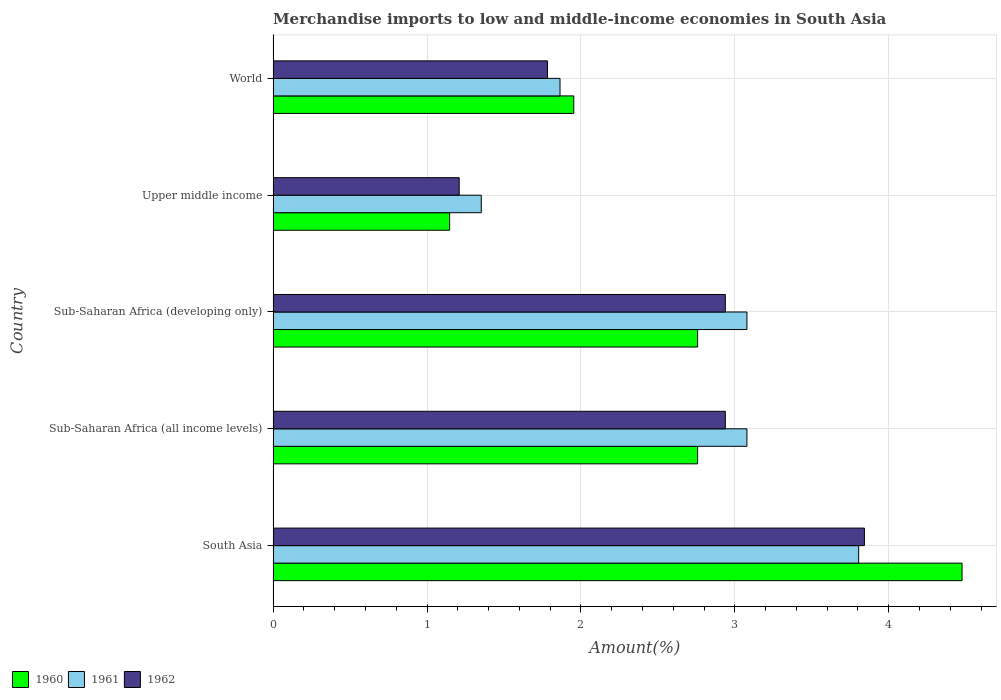How many different coloured bars are there?
Your response must be concise. 3. Are the number of bars on each tick of the Y-axis equal?
Provide a succinct answer. Yes. How many bars are there on the 1st tick from the top?
Offer a very short reply. 3. What is the label of the 1st group of bars from the top?
Your answer should be compact. World. In how many cases, is the number of bars for a given country not equal to the number of legend labels?
Provide a short and direct response. 0. What is the percentage of amount earned from merchandise imports in 1961 in World?
Your response must be concise. 1.86. Across all countries, what is the maximum percentage of amount earned from merchandise imports in 1960?
Provide a succinct answer. 4.48. Across all countries, what is the minimum percentage of amount earned from merchandise imports in 1962?
Your answer should be compact. 1.21. In which country was the percentage of amount earned from merchandise imports in 1961 minimum?
Make the answer very short. Upper middle income. What is the total percentage of amount earned from merchandise imports in 1961 in the graph?
Offer a very short reply. 13.18. What is the difference between the percentage of amount earned from merchandise imports in 1961 in Sub-Saharan Africa (all income levels) and that in Sub-Saharan Africa (developing only)?
Offer a terse response. 0. What is the difference between the percentage of amount earned from merchandise imports in 1960 in Sub-Saharan Africa (all income levels) and the percentage of amount earned from merchandise imports in 1962 in World?
Your answer should be very brief. 0.98. What is the average percentage of amount earned from merchandise imports in 1962 per country?
Your response must be concise. 2.54. What is the difference between the percentage of amount earned from merchandise imports in 1961 and percentage of amount earned from merchandise imports in 1960 in Sub-Saharan Africa (developing only)?
Give a very brief answer. 0.32. What is the ratio of the percentage of amount earned from merchandise imports in 1962 in South Asia to that in Sub-Saharan Africa (all income levels)?
Your response must be concise. 1.31. Is the percentage of amount earned from merchandise imports in 1960 in South Asia less than that in Sub-Saharan Africa (developing only)?
Keep it short and to the point. No. Is the difference between the percentage of amount earned from merchandise imports in 1961 in Sub-Saharan Africa (developing only) and World greater than the difference between the percentage of amount earned from merchandise imports in 1960 in Sub-Saharan Africa (developing only) and World?
Your answer should be very brief. Yes. What is the difference between the highest and the second highest percentage of amount earned from merchandise imports in 1961?
Make the answer very short. 0.73. What is the difference between the highest and the lowest percentage of amount earned from merchandise imports in 1960?
Your answer should be compact. 3.33. In how many countries, is the percentage of amount earned from merchandise imports in 1960 greater than the average percentage of amount earned from merchandise imports in 1960 taken over all countries?
Your response must be concise. 3. Is the sum of the percentage of amount earned from merchandise imports in 1960 in Sub-Saharan Africa (all income levels) and Upper middle income greater than the maximum percentage of amount earned from merchandise imports in 1962 across all countries?
Your answer should be compact. Yes. What does the 2nd bar from the bottom in World represents?
Keep it short and to the point. 1961. Are the values on the major ticks of X-axis written in scientific E-notation?
Keep it short and to the point. No. Where does the legend appear in the graph?
Offer a very short reply. Bottom left. How many legend labels are there?
Give a very brief answer. 3. What is the title of the graph?
Ensure brevity in your answer.  Merchandise imports to low and middle-income economies in South Asia. Does "1993" appear as one of the legend labels in the graph?
Keep it short and to the point. No. What is the label or title of the X-axis?
Offer a very short reply. Amount(%). What is the label or title of the Y-axis?
Offer a terse response. Country. What is the Amount(%) of 1960 in South Asia?
Keep it short and to the point. 4.48. What is the Amount(%) of 1961 in South Asia?
Make the answer very short. 3.8. What is the Amount(%) in 1962 in South Asia?
Offer a very short reply. 3.84. What is the Amount(%) of 1960 in Sub-Saharan Africa (all income levels)?
Keep it short and to the point. 2.76. What is the Amount(%) in 1961 in Sub-Saharan Africa (all income levels)?
Make the answer very short. 3.08. What is the Amount(%) of 1962 in Sub-Saharan Africa (all income levels)?
Offer a very short reply. 2.94. What is the Amount(%) in 1960 in Sub-Saharan Africa (developing only)?
Make the answer very short. 2.76. What is the Amount(%) in 1961 in Sub-Saharan Africa (developing only)?
Your response must be concise. 3.08. What is the Amount(%) in 1962 in Sub-Saharan Africa (developing only)?
Provide a succinct answer. 2.94. What is the Amount(%) in 1960 in Upper middle income?
Offer a very short reply. 1.15. What is the Amount(%) in 1961 in Upper middle income?
Keep it short and to the point. 1.35. What is the Amount(%) of 1962 in Upper middle income?
Your answer should be very brief. 1.21. What is the Amount(%) in 1960 in World?
Keep it short and to the point. 1.95. What is the Amount(%) in 1961 in World?
Ensure brevity in your answer.  1.86. What is the Amount(%) in 1962 in World?
Offer a very short reply. 1.78. Across all countries, what is the maximum Amount(%) of 1960?
Offer a terse response. 4.48. Across all countries, what is the maximum Amount(%) in 1961?
Your answer should be compact. 3.8. Across all countries, what is the maximum Amount(%) of 1962?
Keep it short and to the point. 3.84. Across all countries, what is the minimum Amount(%) of 1960?
Ensure brevity in your answer.  1.15. Across all countries, what is the minimum Amount(%) of 1961?
Offer a terse response. 1.35. Across all countries, what is the minimum Amount(%) in 1962?
Offer a very short reply. 1.21. What is the total Amount(%) of 1960 in the graph?
Offer a very short reply. 13.09. What is the total Amount(%) in 1961 in the graph?
Make the answer very short. 13.18. What is the total Amount(%) in 1962 in the graph?
Your answer should be compact. 12.71. What is the difference between the Amount(%) of 1960 in South Asia and that in Sub-Saharan Africa (all income levels)?
Provide a succinct answer. 1.72. What is the difference between the Amount(%) in 1961 in South Asia and that in Sub-Saharan Africa (all income levels)?
Keep it short and to the point. 0.73. What is the difference between the Amount(%) of 1962 in South Asia and that in Sub-Saharan Africa (all income levels)?
Offer a very short reply. 0.9. What is the difference between the Amount(%) in 1960 in South Asia and that in Sub-Saharan Africa (developing only)?
Give a very brief answer. 1.72. What is the difference between the Amount(%) in 1961 in South Asia and that in Sub-Saharan Africa (developing only)?
Provide a short and direct response. 0.73. What is the difference between the Amount(%) of 1962 in South Asia and that in Sub-Saharan Africa (developing only)?
Your answer should be very brief. 0.9. What is the difference between the Amount(%) of 1960 in South Asia and that in Upper middle income?
Provide a short and direct response. 3.33. What is the difference between the Amount(%) of 1961 in South Asia and that in Upper middle income?
Your answer should be very brief. 2.45. What is the difference between the Amount(%) of 1962 in South Asia and that in Upper middle income?
Your answer should be compact. 2.63. What is the difference between the Amount(%) in 1960 in South Asia and that in World?
Your response must be concise. 2.52. What is the difference between the Amount(%) in 1961 in South Asia and that in World?
Your response must be concise. 1.94. What is the difference between the Amount(%) in 1962 in South Asia and that in World?
Your response must be concise. 2.06. What is the difference between the Amount(%) in 1961 in Sub-Saharan Africa (all income levels) and that in Sub-Saharan Africa (developing only)?
Provide a succinct answer. 0. What is the difference between the Amount(%) of 1960 in Sub-Saharan Africa (all income levels) and that in Upper middle income?
Your answer should be compact. 1.61. What is the difference between the Amount(%) in 1961 in Sub-Saharan Africa (all income levels) and that in Upper middle income?
Keep it short and to the point. 1.73. What is the difference between the Amount(%) of 1962 in Sub-Saharan Africa (all income levels) and that in Upper middle income?
Your answer should be compact. 1.73. What is the difference between the Amount(%) of 1960 in Sub-Saharan Africa (all income levels) and that in World?
Provide a succinct answer. 0.8. What is the difference between the Amount(%) of 1961 in Sub-Saharan Africa (all income levels) and that in World?
Keep it short and to the point. 1.21. What is the difference between the Amount(%) in 1962 in Sub-Saharan Africa (all income levels) and that in World?
Make the answer very short. 1.16. What is the difference between the Amount(%) in 1960 in Sub-Saharan Africa (developing only) and that in Upper middle income?
Offer a very short reply. 1.61. What is the difference between the Amount(%) in 1961 in Sub-Saharan Africa (developing only) and that in Upper middle income?
Provide a short and direct response. 1.73. What is the difference between the Amount(%) in 1962 in Sub-Saharan Africa (developing only) and that in Upper middle income?
Give a very brief answer. 1.73. What is the difference between the Amount(%) in 1960 in Sub-Saharan Africa (developing only) and that in World?
Provide a succinct answer. 0.8. What is the difference between the Amount(%) in 1961 in Sub-Saharan Africa (developing only) and that in World?
Provide a short and direct response. 1.21. What is the difference between the Amount(%) in 1962 in Sub-Saharan Africa (developing only) and that in World?
Your response must be concise. 1.16. What is the difference between the Amount(%) of 1960 in Upper middle income and that in World?
Provide a succinct answer. -0.81. What is the difference between the Amount(%) of 1961 in Upper middle income and that in World?
Keep it short and to the point. -0.51. What is the difference between the Amount(%) in 1962 in Upper middle income and that in World?
Provide a succinct answer. -0.57. What is the difference between the Amount(%) of 1960 in South Asia and the Amount(%) of 1961 in Sub-Saharan Africa (all income levels)?
Provide a short and direct response. 1.4. What is the difference between the Amount(%) of 1960 in South Asia and the Amount(%) of 1962 in Sub-Saharan Africa (all income levels)?
Your answer should be very brief. 1.54. What is the difference between the Amount(%) of 1961 in South Asia and the Amount(%) of 1962 in Sub-Saharan Africa (all income levels)?
Provide a succinct answer. 0.87. What is the difference between the Amount(%) in 1960 in South Asia and the Amount(%) in 1961 in Sub-Saharan Africa (developing only)?
Make the answer very short. 1.4. What is the difference between the Amount(%) of 1960 in South Asia and the Amount(%) of 1962 in Sub-Saharan Africa (developing only)?
Provide a short and direct response. 1.54. What is the difference between the Amount(%) of 1961 in South Asia and the Amount(%) of 1962 in Sub-Saharan Africa (developing only)?
Your answer should be very brief. 0.87. What is the difference between the Amount(%) of 1960 in South Asia and the Amount(%) of 1961 in Upper middle income?
Your response must be concise. 3.12. What is the difference between the Amount(%) in 1960 in South Asia and the Amount(%) in 1962 in Upper middle income?
Keep it short and to the point. 3.27. What is the difference between the Amount(%) of 1961 in South Asia and the Amount(%) of 1962 in Upper middle income?
Offer a very short reply. 2.6. What is the difference between the Amount(%) of 1960 in South Asia and the Amount(%) of 1961 in World?
Ensure brevity in your answer.  2.61. What is the difference between the Amount(%) in 1960 in South Asia and the Amount(%) in 1962 in World?
Ensure brevity in your answer.  2.69. What is the difference between the Amount(%) in 1961 in South Asia and the Amount(%) in 1962 in World?
Ensure brevity in your answer.  2.02. What is the difference between the Amount(%) of 1960 in Sub-Saharan Africa (all income levels) and the Amount(%) of 1961 in Sub-Saharan Africa (developing only)?
Provide a short and direct response. -0.32. What is the difference between the Amount(%) in 1960 in Sub-Saharan Africa (all income levels) and the Amount(%) in 1962 in Sub-Saharan Africa (developing only)?
Give a very brief answer. -0.18. What is the difference between the Amount(%) in 1961 in Sub-Saharan Africa (all income levels) and the Amount(%) in 1962 in Sub-Saharan Africa (developing only)?
Provide a short and direct response. 0.14. What is the difference between the Amount(%) of 1960 in Sub-Saharan Africa (all income levels) and the Amount(%) of 1961 in Upper middle income?
Your response must be concise. 1.41. What is the difference between the Amount(%) of 1960 in Sub-Saharan Africa (all income levels) and the Amount(%) of 1962 in Upper middle income?
Give a very brief answer. 1.55. What is the difference between the Amount(%) of 1961 in Sub-Saharan Africa (all income levels) and the Amount(%) of 1962 in Upper middle income?
Give a very brief answer. 1.87. What is the difference between the Amount(%) of 1960 in Sub-Saharan Africa (all income levels) and the Amount(%) of 1961 in World?
Keep it short and to the point. 0.89. What is the difference between the Amount(%) in 1960 in Sub-Saharan Africa (all income levels) and the Amount(%) in 1962 in World?
Your response must be concise. 0.98. What is the difference between the Amount(%) in 1961 in Sub-Saharan Africa (all income levels) and the Amount(%) in 1962 in World?
Ensure brevity in your answer.  1.3. What is the difference between the Amount(%) of 1960 in Sub-Saharan Africa (developing only) and the Amount(%) of 1961 in Upper middle income?
Make the answer very short. 1.41. What is the difference between the Amount(%) of 1960 in Sub-Saharan Africa (developing only) and the Amount(%) of 1962 in Upper middle income?
Your response must be concise. 1.55. What is the difference between the Amount(%) of 1961 in Sub-Saharan Africa (developing only) and the Amount(%) of 1962 in Upper middle income?
Offer a terse response. 1.87. What is the difference between the Amount(%) of 1960 in Sub-Saharan Africa (developing only) and the Amount(%) of 1961 in World?
Give a very brief answer. 0.89. What is the difference between the Amount(%) in 1960 in Sub-Saharan Africa (developing only) and the Amount(%) in 1962 in World?
Offer a terse response. 0.98. What is the difference between the Amount(%) in 1961 in Sub-Saharan Africa (developing only) and the Amount(%) in 1962 in World?
Offer a very short reply. 1.3. What is the difference between the Amount(%) of 1960 in Upper middle income and the Amount(%) of 1961 in World?
Your answer should be very brief. -0.72. What is the difference between the Amount(%) in 1960 in Upper middle income and the Amount(%) in 1962 in World?
Make the answer very short. -0.64. What is the difference between the Amount(%) of 1961 in Upper middle income and the Amount(%) of 1962 in World?
Your response must be concise. -0.43. What is the average Amount(%) in 1960 per country?
Your answer should be compact. 2.62. What is the average Amount(%) of 1961 per country?
Your answer should be very brief. 2.64. What is the average Amount(%) of 1962 per country?
Make the answer very short. 2.54. What is the difference between the Amount(%) in 1960 and Amount(%) in 1961 in South Asia?
Provide a short and direct response. 0.67. What is the difference between the Amount(%) in 1960 and Amount(%) in 1962 in South Asia?
Provide a succinct answer. 0.63. What is the difference between the Amount(%) of 1961 and Amount(%) of 1962 in South Asia?
Your answer should be compact. -0.04. What is the difference between the Amount(%) of 1960 and Amount(%) of 1961 in Sub-Saharan Africa (all income levels)?
Ensure brevity in your answer.  -0.32. What is the difference between the Amount(%) in 1960 and Amount(%) in 1962 in Sub-Saharan Africa (all income levels)?
Give a very brief answer. -0.18. What is the difference between the Amount(%) of 1961 and Amount(%) of 1962 in Sub-Saharan Africa (all income levels)?
Offer a very short reply. 0.14. What is the difference between the Amount(%) in 1960 and Amount(%) in 1961 in Sub-Saharan Africa (developing only)?
Give a very brief answer. -0.32. What is the difference between the Amount(%) in 1960 and Amount(%) in 1962 in Sub-Saharan Africa (developing only)?
Give a very brief answer. -0.18. What is the difference between the Amount(%) in 1961 and Amount(%) in 1962 in Sub-Saharan Africa (developing only)?
Your answer should be compact. 0.14. What is the difference between the Amount(%) of 1960 and Amount(%) of 1961 in Upper middle income?
Provide a succinct answer. -0.21. What is the difference between the Amount(%) of 1960 and Amount(%) of 1962 in Upper middle income?
Ensure brevity in your answer.  -0.06. What is the difference between the Amount(%) in 1961 and Amount(%) in 1962 in Upper middle income?
Your response must be concise. 0.14. What is the difference between the Amount(%) of 1960 and Amount(%) of 1961 in World?
Keep it short and to the point. 0.09. What is the difference between the Amount(%) of 1960 and Amount(%) of 1962 in World?
Make the answer very short. 0.17. What is the difference between the Amount(%) of 1961 and Amount(%) of 1962 in World?
Give a very brief answer. 0.08. What is the ratio of the Amount(%) in 1960 in South Asia to that in Sub-Saharan Africa (all income levels)?
Your answer should be very brief. 1.62. What is the ratio of the Amount(%) in 1961 in South Asia to that in Sub-Saharan Africa (all income levels)?
Your response must be concise. 1.24. What is the ratio of the Amount(%) of 1962 in South Asia to that in Sub-Saharan Africa (all income levels)?
Give a very brief answer. 1.31. What is the ratio of the Amount(%) in 1960 in South Asia to that in Sub-Saharan Africa (developing only)?
Offer a terse response. 1.62. What is the ratio of the Amount(%) in 1961 in South Asia to that in Sub-Saharan Africa (developing only)?
Your response must be concise. 1.24. What is the ratio of the Amount(%) of 1962 in South Asia to that in Sub-Saharan Africa (developing only)?
Offer a terse response. 1.31. What is the ratio of the Amount(%) of 1960 in South Asia to that in Upper middle income?
Provide a succinct answer. 3.9. What is the ratio of the Amount(%) of 1961 in South Asia to that in Upper middle income?
Offer a very short reply. 2.81. What is the ratio of the Amount(%) in 1962 in South Asia to that in Upper middle income?
Give a very brief answer. 3.18. What is the ratio of the Amount(%) of 1960 in South Asia to that in World?
Ensure brevity in your answer.  2.29. What is the ratio of the Amount(%) of 1961 in South Asia to that in World?
Your response must be concise. 2.04. What is the ratio of the Amount(%) in 1962 in South Asia to that in World?
Keep it short and to the point. 2.16. What is the ratio of the Amount(%) of 1961 in Sub-Saharan Africa (all income levels) to that in Sub-Saharan Africa (developing only)?
Your answer should be compact. 1. What is the ratio of the Amount(%) of 1960 in Sub-Saharan Africa (all income levels) to that in Upper middle income?
Make the answer very short. 2.4. What is the ratio of the Amount(%) of 1961 in Sub-Saharan Africa (all income levels) to that in Upper middle income?
Give a very brief answer. 2.28. What is the ratio of the Amount(%) in 1962 in Sub-Saharan Africa (all income levels) to that in Upper middle income?
Keep it short and to the point. 2.43. What is the ratio of the Amount(%) of 1960 in Sub-Saharan Africa (all income levels) to that in World?
Your response must be concise. 1.41. What is the ratio of the Amount(%) of 1961 in Sub-Saharan Africa (all income levels) to that in World?
Give a very brief answer. 1.65. What is the ratio of the Amount(%) of 1962 in Sub-Saharan Africa (all income levels) to that in World?
Provide a succinct answer. 1.65. What is the ratio of the Amount(%) of 1960 in Sub-Saharan Africa (developing only) to that in Upper middle income?
Make the answer very short. 2.4. What is the ratio of the Amount(%) of 1961 in Sub-Saharan Africa (developing only) to that in Upper middle income?
Your answer should be very brief. 2.28. What is the ratio of the Amount(%) of 1962 in Sub-Saharan Africa (developing only) to that in Upper middle income?
Your answer should be very brief. 2.43. What is the ratio of the Amount(%) in 1960 in Sub-Saharan Africa (developing only) to that in World?
Your response must be concise. 1.41. What is the ratio of the Amount(%) in 1961 in Sub-Saharan Africa (developing only) to that in World?
Make the answer very short. 1.65. What is the ratio of the Amount(%) of 1962 in Sub-Saharan Africa (developing only) to that in World?
Ensure brevity in your answer.  1.65. What is the ratio of the Amount(%) of 1960 in Upper middle income to that in World?
Give a very brief answer. 0.59. What is the ratio of the Amount(%) of 1961 in Upper middle income to that in World?
Your answer should be very brief. 0.73. What is the ratio of the Amount(%) in 1962 in Upper middle income to that in World?
Offer a terse response. 0.68. What is the difference between the highest and the second highest Amount(%) in 1960?
Provide a succinct answer. 1.72. What is the difference between the highest and the second highest Amount(%) in 1961?
Provide a short and direct response. 0.73. What is the difference between the highest and the second highest Amount(%) of 1962?
Offer a terse response. 0.9. What is the difference between the highest and the lowest Amount(%) of 1960?
Offer a terse response. 3.33. What is the difference between the highest and the lowest Amount(%) in 1961?
Give a very brief answer. 2.45. What is the difference between the highest and the lowest Amount(%) in 1962?
Your response must be concise. 2.63. 